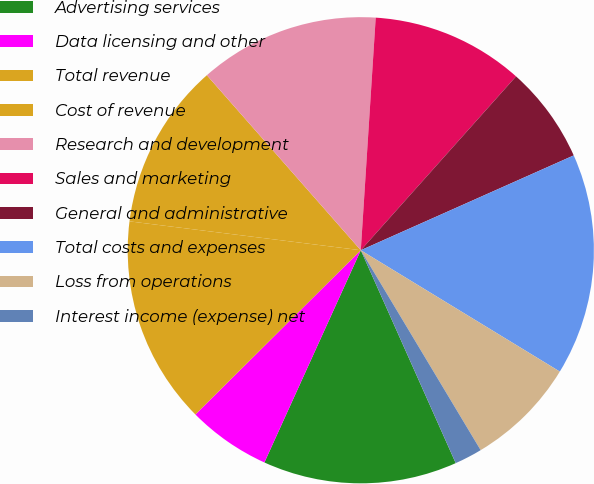Convert chart. <chart><loc_0><loc_0><loc_500><loc_500><pie_chart><fcel>Advertising services<fcel>Data licensing and other<fcel>Total revenue<fcel>Cost of revenue<fcel>Research and development<fcel>Sales and marketing<fcel>General and administrative<fcel>Total costs and expenses<fcel>Loss from operations<fcel>Interest income (expense) net<nl><fcel>13.46%<fcel>5.77%<fcel>14.42%<fcel>11.54%<fcel>12.5%<fcel>10.58%<fcel>6.73%<fcel>15.38%<fcel>7.69%<fcel>1.92%<nl></chart> 